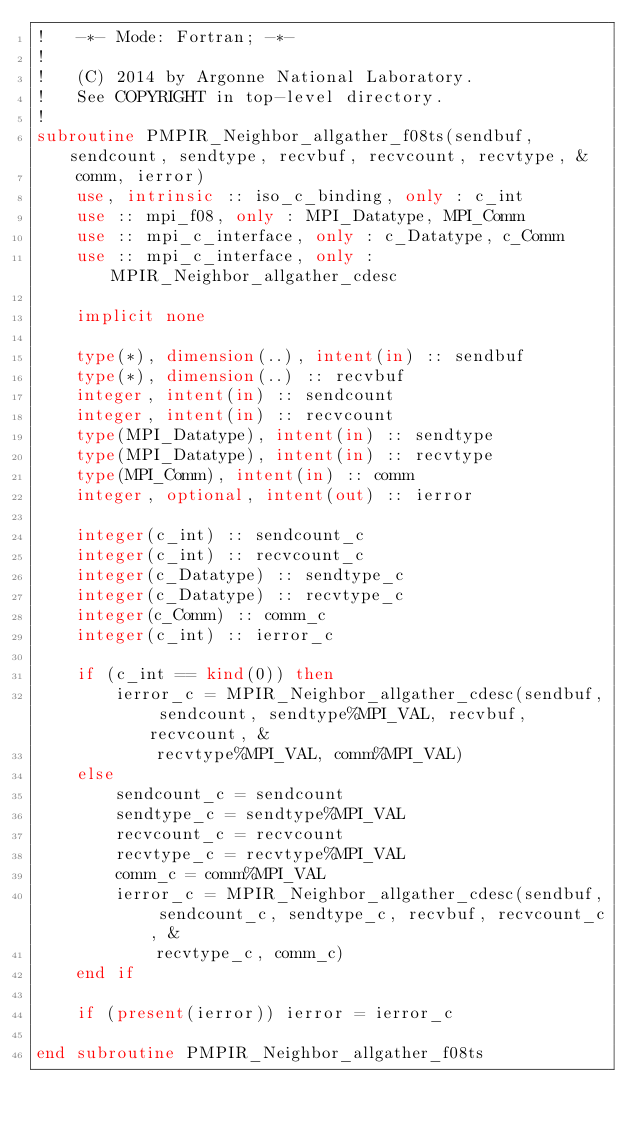<code> <loc_0><loc_0><loc_500><loc_500><_FORTRAN_>!   -*- Mode: Fortran; -*-
!
!   (C) 2014 by Argonne National Laboratory.
!   See COPYRIGHT in top-level directory.
!
subroutine PMPIR_Neighbor_allgather_f08ts(sendbuf, sendcount, sendtype, recvbuf, recvcount, recvtype, &
    comm, ierror)
    use, intrinsic :: iso_c_binding, only : c_int
    use :: mpi_f08, only : MPI_Datatype, MPI_Comm
    use :: mpi_c_interface, only : c_Datatype, c_Comm
    use :: mpi_c_interface, only : MPIR_Neighbor_allgather_cdesc

    implicit none

    type(*), dimension(..), intent(in) :: sendbuf
    type(*), dimension(..) :: recvbuf
    integer, intent(in) :: sendcount
    integer, intent(in) :: recvcount
    type(MPI_Datatype), intent(in) :: sendtype
    type(MPI_Datatype), intent(in) :: recvtype
    type(MPI_Comm), intent(in) :: comm
    integer, optional, intent(out) :: ierror

    integer(c_int) :: sendcount_c
    integer(c_int) :: recvcount_c
    integer(c_Datatype) :: sendtype_c
    integer(c_Datatype) :: recvtype_c
    integer(c_Comm) :: comm_c
    integer(c_int) :: ierror_c

    if (c_int == kind(0)) then
        ierror_c = MPIR_Neighbor_allgather_cdesc(sendbuf, sendcount, sendtype%MPI_VAL, recvbuf, recvcount, &
            recvtype%MPI_VAL, comm%MPI_VAL)
    else
        sendcount_c = sendcount
        sendtype_c = sendtype%MPI_VAL
        recvcount_c = recvcount
        recvtype_c = recvtype%MPI_VAL
        comm_c = comm%MPI_VAL
        ierror_c = MPIR_Neighbor_allgather_cdesc(sendbuf, sendcount_c, sendtype_c, recvbuf, recvcount_c, &
            recvtype_c, comm_c)
    end if

    if (present(ierror)) ierror = ierror_c

end subroutine PMPIR_Neighbor_allgather_f08ts
</code> 